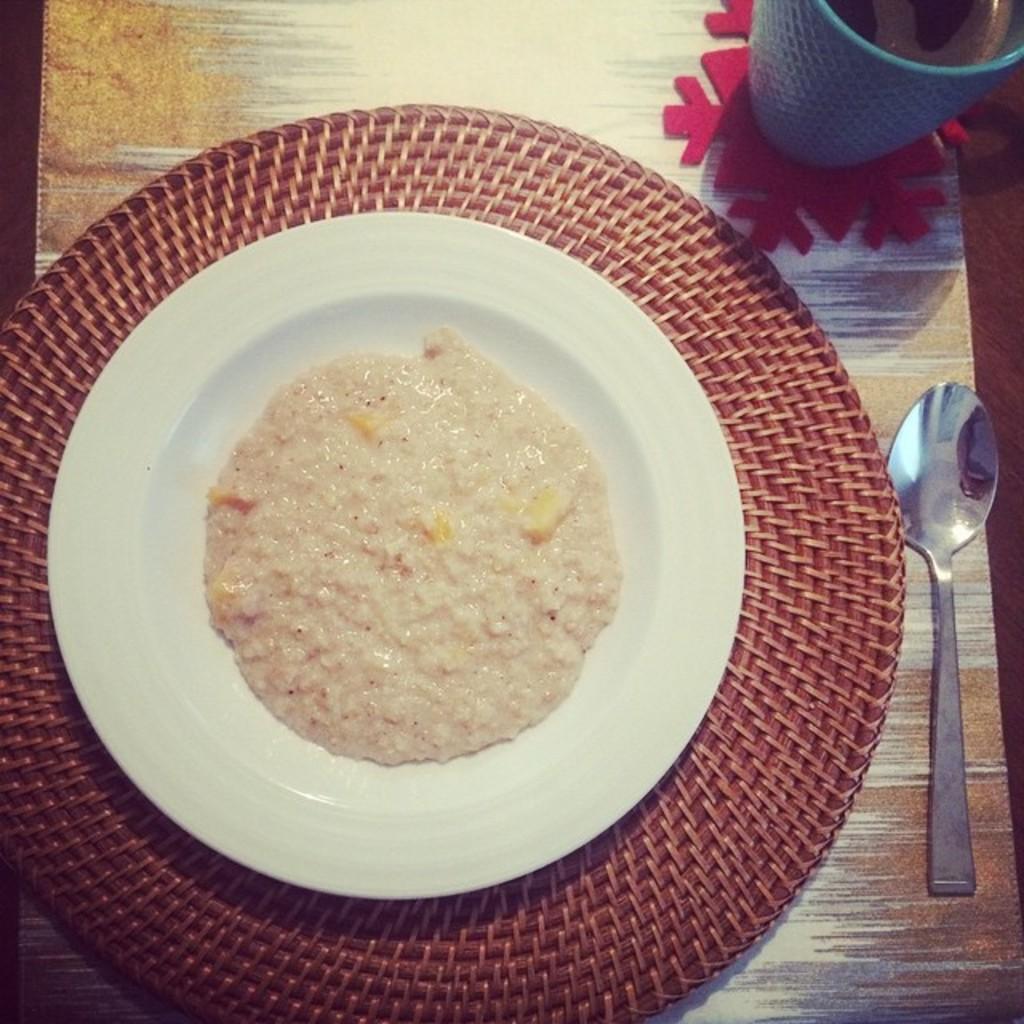Could you give a brief overview of what you see in this image? On a table there is a food item on a plate. There is a spoon and a mug which has drink. 